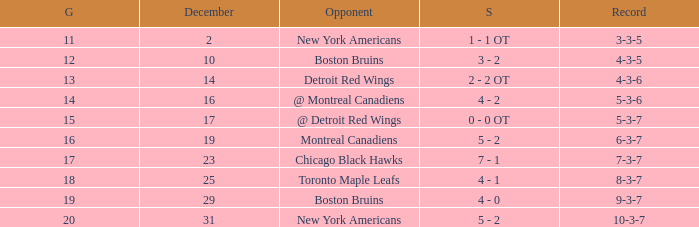Which Game is the highest one that has a Record of 4-3-6? 13.0. 